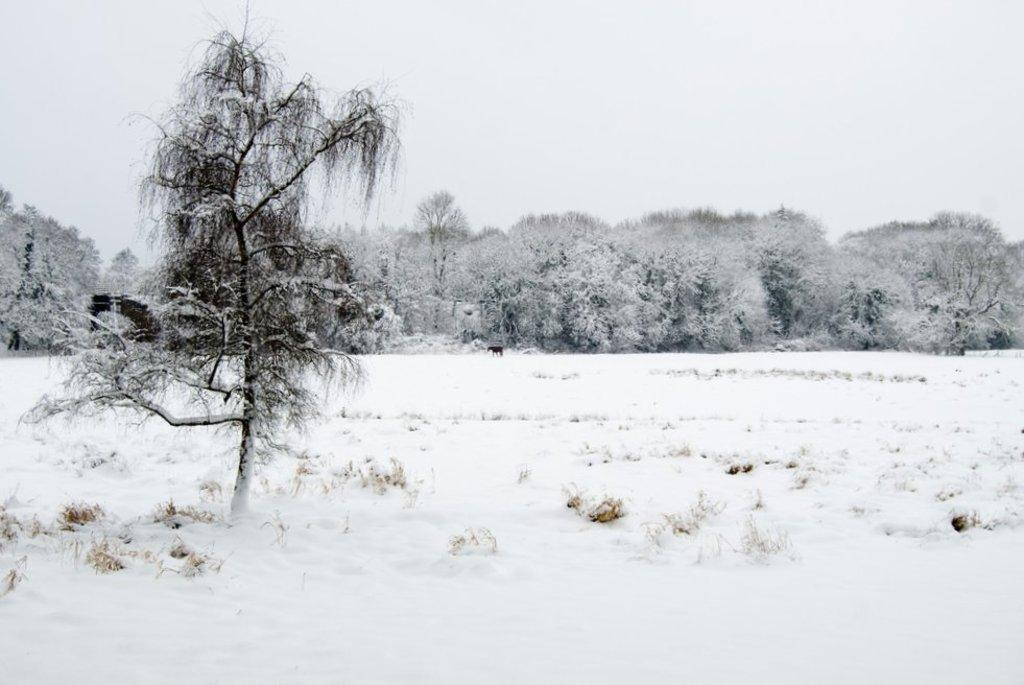What type of vegetation can be seen in the image? There are trees in the image. What is covering the ground in the image? There is snow and grass visible in the image. What can be seen in the background of the image? The sky is visible in the background of the image. What type of duck can be seen swimming in the snow in the image? There is no duck present in the image; it features trees, snow, grass, and the sky. What part of the brain can be seen in the image? There is no brain present in the image; it is a natural scene with trees, snow, grass, and the sky. 